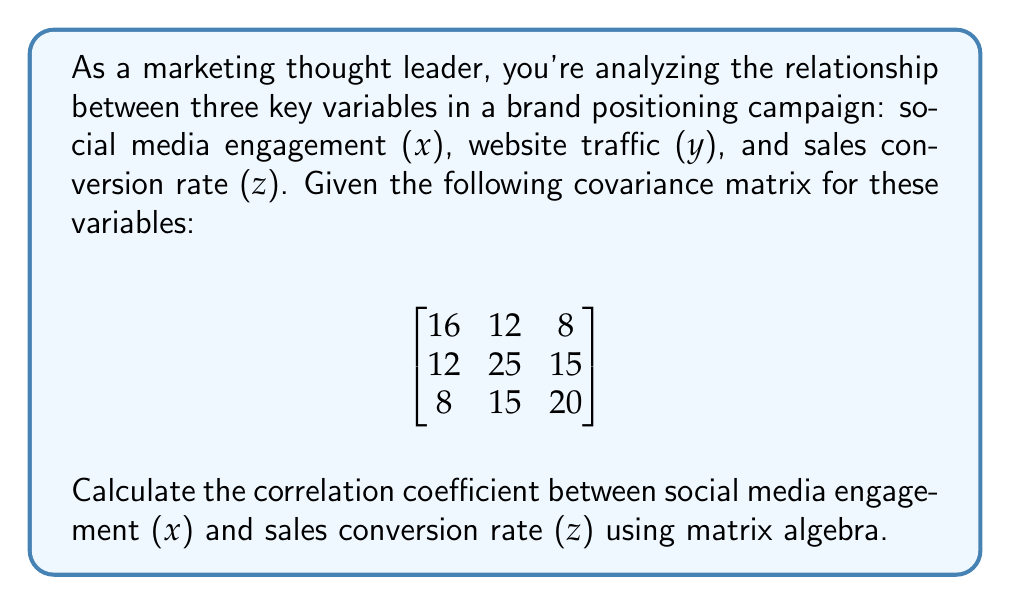Can you answer this question? To calculate the correlation coefficient between x and z using matrix algebra, we'll follow these steps:

1. Recall the formula for correlation coefficient:
   $$r_{xz} = \frac{Cov(x,z)}{\sqrt{Var(x) \cdot Var(z)}}$$

2. From the given covariance matrix, we can identify:
   - $Var(x) = 16$ (top-left element)
   - $Var(z) = 20$ (bottom-right element)
   - $Cov(x,z) = 8$ (top-right or bottom-left element)

3. Substitute these values into the correlation coefficient formula:
   $$r_{xz} = \frac{8}{\sqrt{16 \cdot 20}}$$

4. Simplify:
   $$r_{xz} = \frac{8}{\sqrt{320}}$$

5. Simplify further:
   $$r_{xz} = \frac{8}{\sqrt{16 \cdot 20}} = \frac{8}{4\sqrt{5}} = \frac{2}{\sqrt{5}}$$

6. The final correlation coefficient can be left as $\frac{2}{\sqrt{5}}$ or approximated to a decimal:
   $$r_{xz} \approx 0.8944$$

This correlation coefficient indicates a strong positive relationship between social media engagement and sales conversion rate in your brand positioning campaign.
Answer: $\frac{2}{\sqrt{5}}$ or approximately 0.8944 